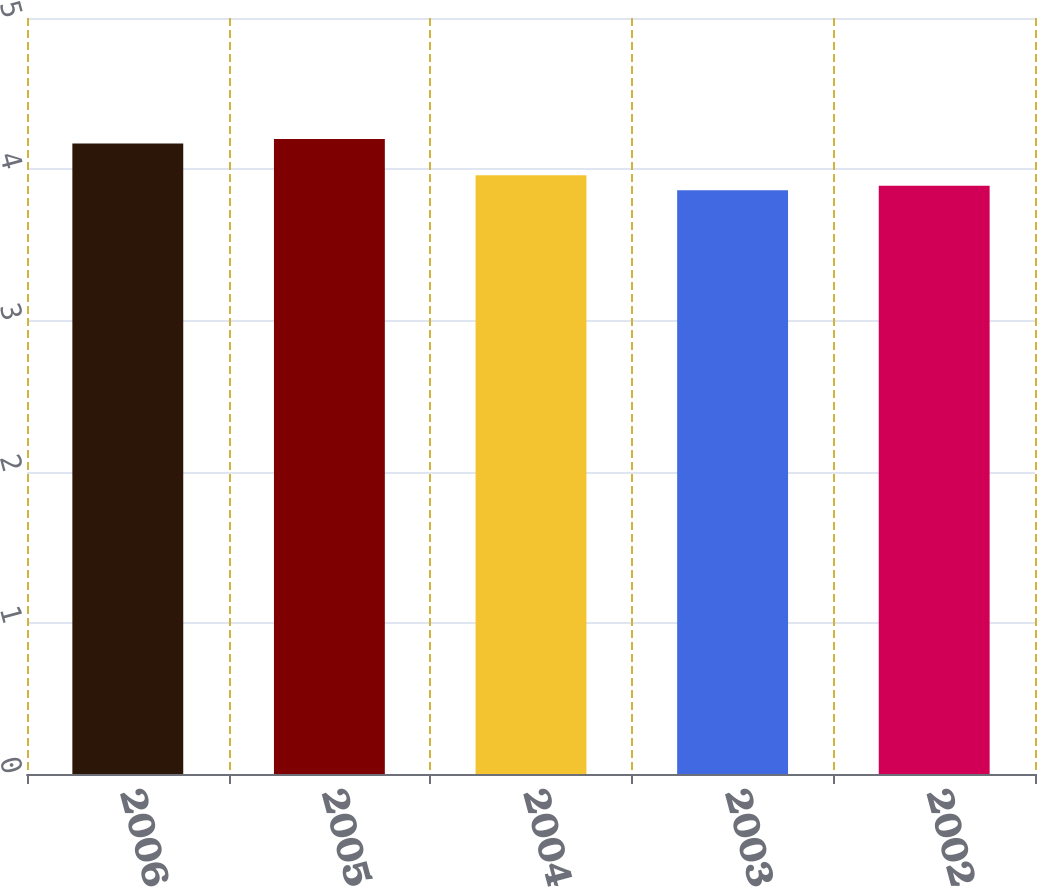Convert chart to OTSL. <chart><loc_0><loc_0><loc_500><loc_500><bar_chart><fcel>2006<fcel>2005<fcel>2004<fcel>2003<fcel>2002<nl><fcel>4.17<fcel>4.2<fcel>3.96<fcel>3.86<fcel>3.89<nl></chart> 